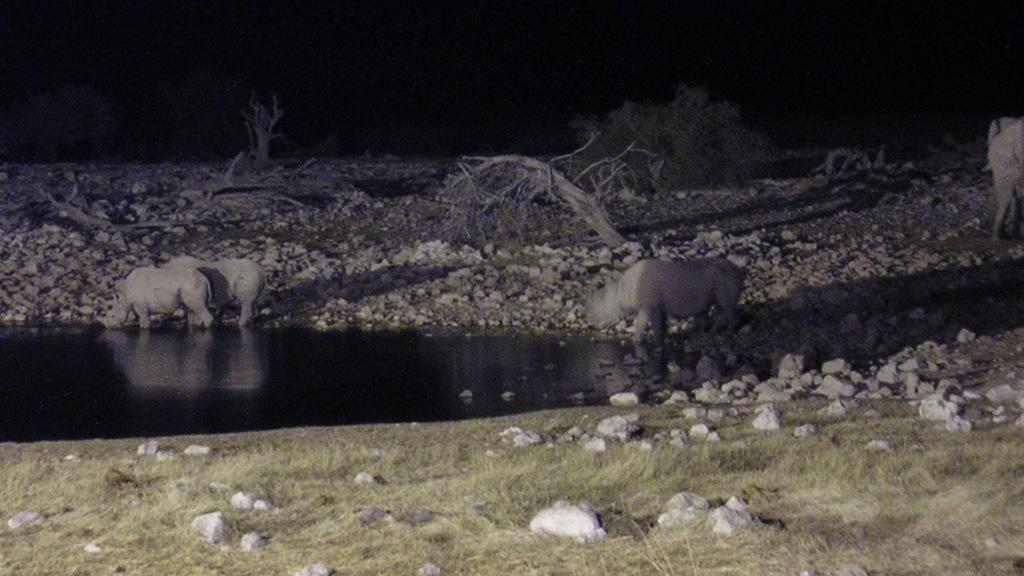What animals can be seen in the image? There are rhinoceros in the image. What are the rhinoceros doing in the image? The rhinoceros are drinking water from a pond. How would you describe the terrain in the image? The land in the image is covered with stones. Are there any plants visible in the image? Dry trees are present in the image. What religious symbol can be seen in the image? There is no religious symbol present in the image; it features rhinoceros drinking water from a pond, stones, and dry trees. 